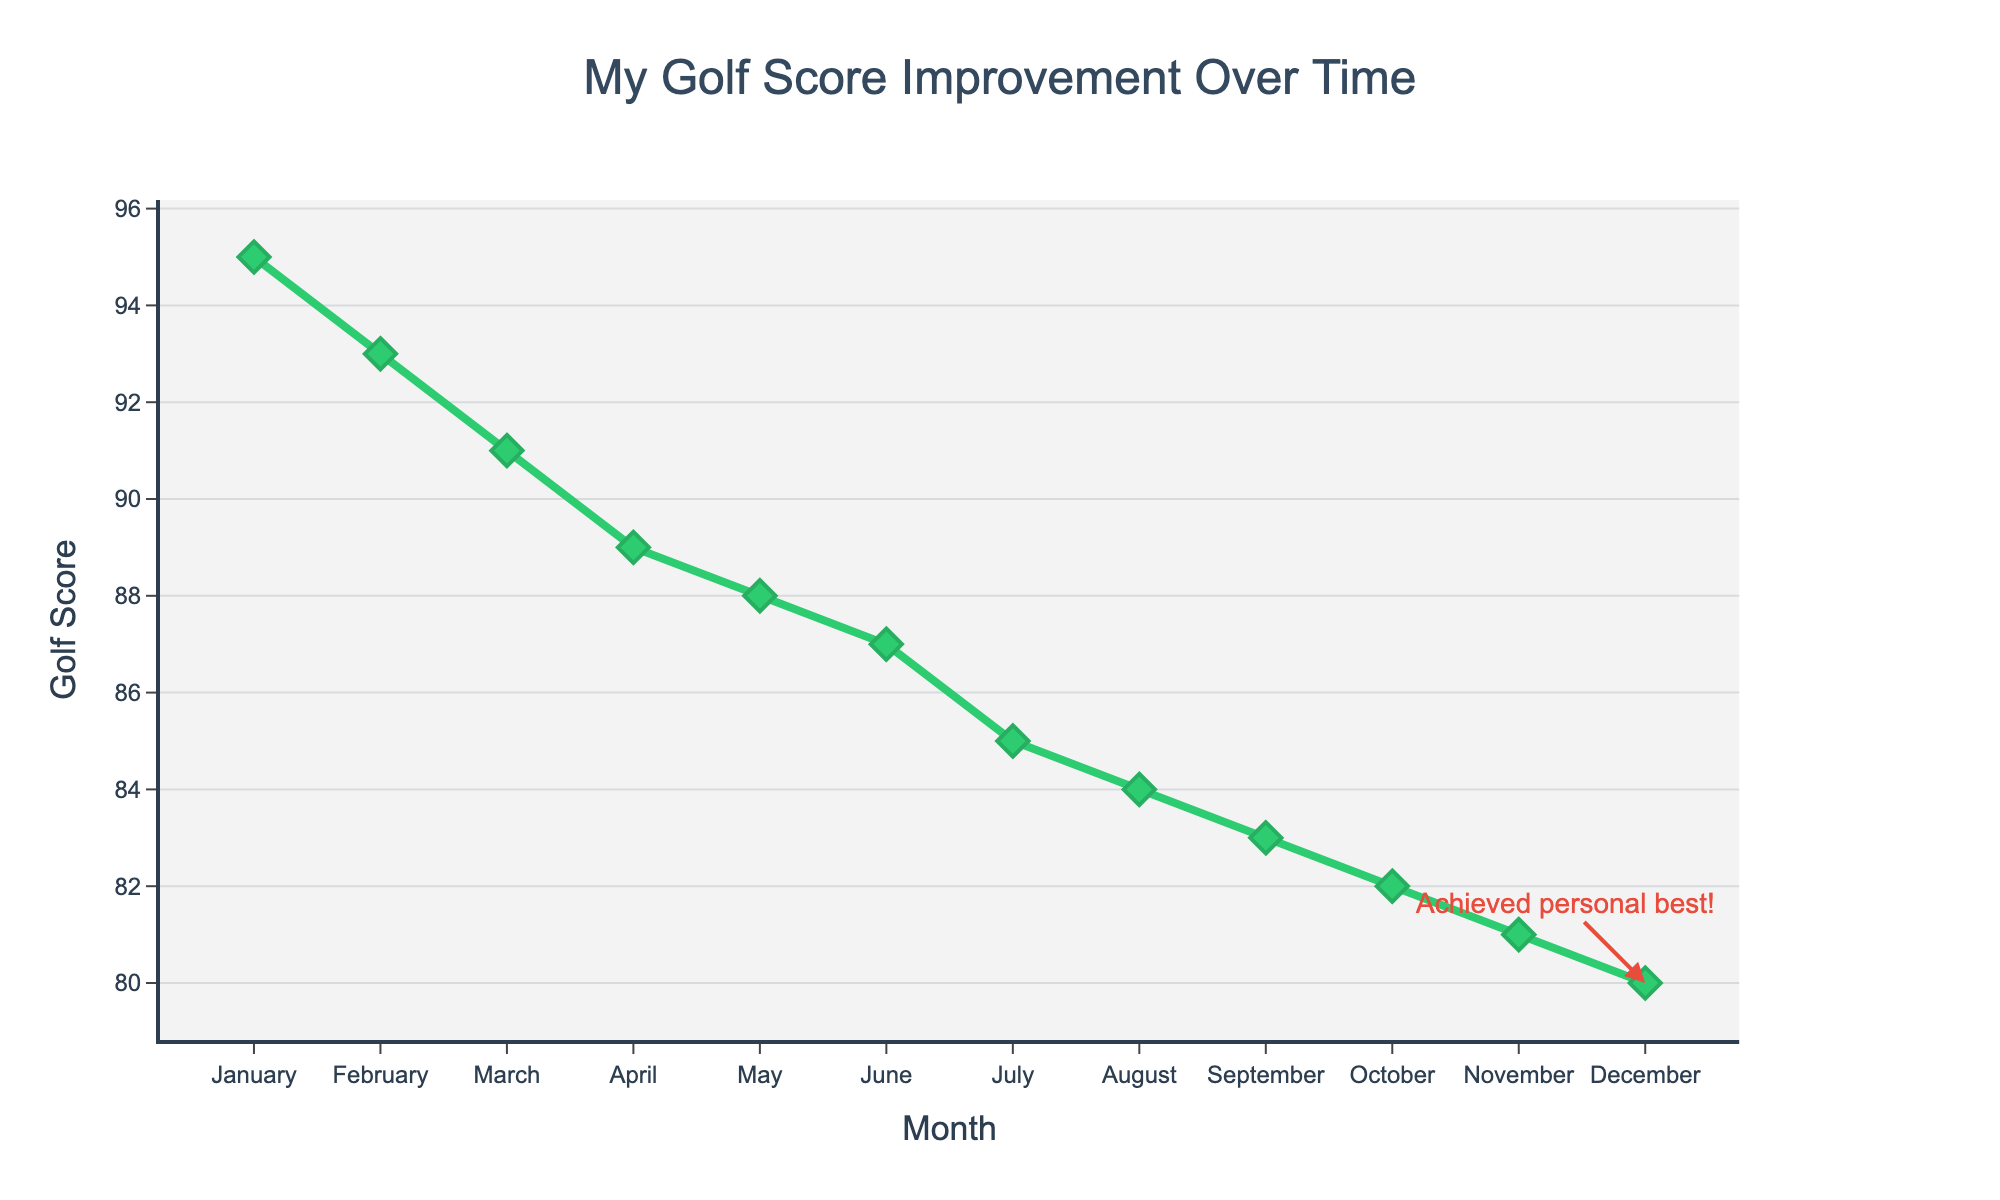How many months of data are displayed in the figure? Count the number of data points on the x-axis, which represent the months from January to December.
Answer: 12 What's the overall trend in the golf scores over the months? Observe the direction of the line on the plot. It shows that the golf scores decrease over time.
Answer: Decreasing Which month shows the highest golf score? Look at the highest point on the y-axis and identify the corresponding month on the x-axis.
Answer: January By how many points did the golf score improve from January to December? Subtract the golf score in December from the score in January: 95 - 80.
Answer: 15 In which month did the golf score decrease by the largest amount compared to the previous month? Calculate the monthly differences and compare: Jan-Feb (2), Feb-Mar (2), Mar-Apr (2), Apr-May (1), May-Jun (1), Jun-Jul (2), Jul-Aug (1), Aug-Sep (1), Sep-Oct (1), Oct-Nov (1), Nov-Dec (1).
Answer: March What is the title of the figure? Read the text displayed at the top of the figure.
Answer: My Golf Score Improvement Over Time When did the achieved personal best golf score occur? Look for the annotation in the figure. It points to December with the text "Achieved personal best!"
Answer: December What is the trend of the golf score from February to April? Observe the line segment from February to April and see if it is going up or down.
Answer: Decreasing Which data point has a score exactly one point less than the previous month? By observing the differences between consecutive months: May (88) to June (87).
Answer: June What is the average golf score for the first six months? Sum the scores from January to June: 95, 93, 91, 89, 88, 87, then divide by 6. (95 + 93 + 91 + 89 + 88 + 87) / 6 = 90.5
Answer: 90.5 